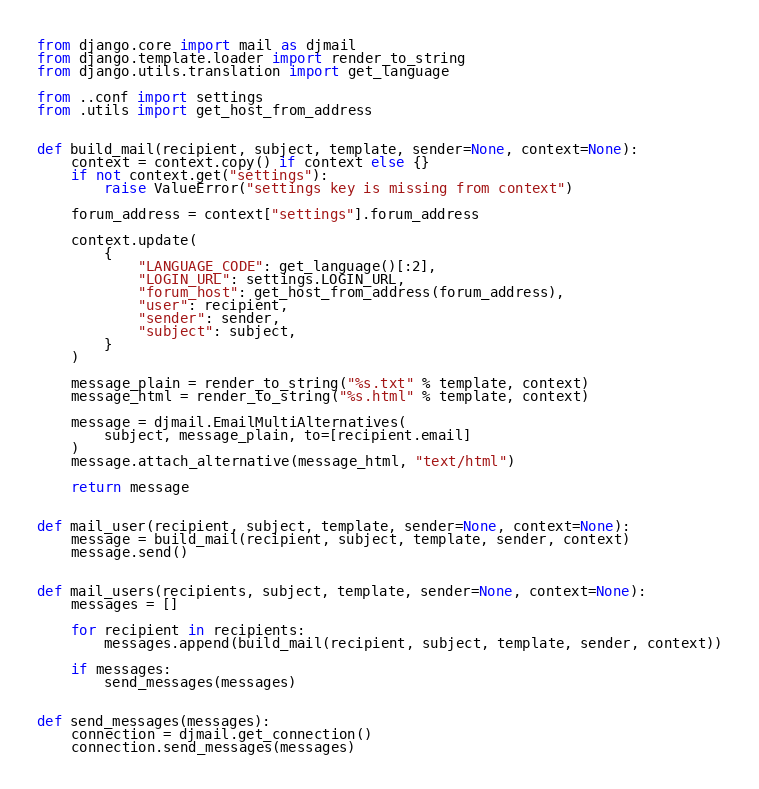<code> <loc_0><loc_0><loc_500><loc_500><_Python_>from django.core import mail as djmail
from django.template.loader import render_to_string
from django.utils.translation import get_language

from ..conf import settings
from .utils import get_host_from_address


def build_mail(recipient, subject, template, sender=None, context=None):
    context = context.copy() if context else {}
    if not context.get("settings"):
        raise ValueError("settings key is missing from context")

    forum_address = context["settings"].forum_address

    context.update(
        {
            "LANGUAGE_CODE": get_language()[:2],
            "LOGIN_URL": settings.LOGIN_URL,
            "forum_host": get_host_from_address(forum_address),
            "user": recipient,
            "sender": sender,
            "subject": subject,
        }
    )

    message_plain = render_to_string("%s.txt" % template, context)
    message_html = render_to_string("%s.html" % template, context)

    message = djmail.EmailMultiAlternatives(
        subject, message_plain, to=[recipient.email]
    )
    message.attach_alternative(message_html, "text/html")

    return message


def mail_user(recipient, subject, template, sender=None, context=None):
    message = build_mail(recipient, subject, template, sender, context)
    message.send()


def mail_users(recipients, subject, template, sender=None, context=None):
    messages = []

    for recipient in recipients:
        messages.append(build_mail(recipient, subject, template, sender, context))

    if messages:
        send_messages(messages)


def send_messages(messages):
    connection = djmail.get_connection()
    connection.send_messages(messages)
</code> 